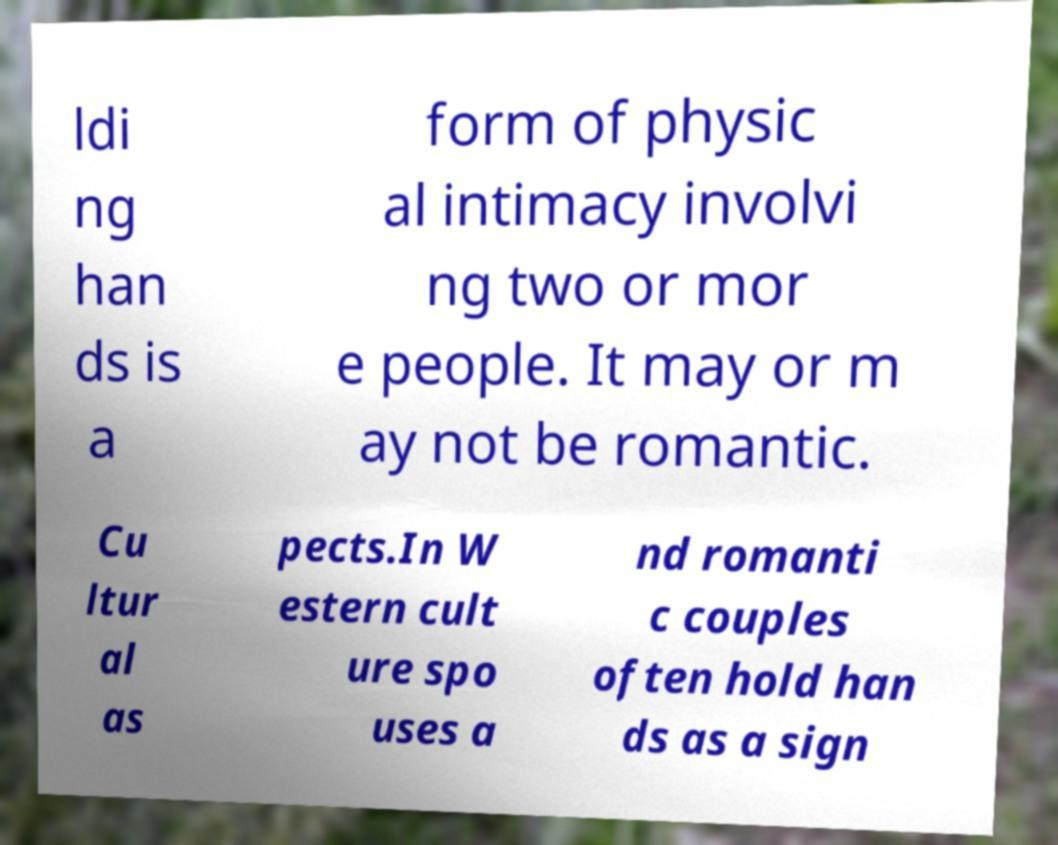Can you accurately transcribe the text from the provided image for me? ldi ng han ds is a form of physic al intimacy involvi ng two or mor e people. It may or m ay not be romantic. Cu ltur al as pects.In W estern cult ure spo uses a nd romanti c couples often hold han ds as a sign 